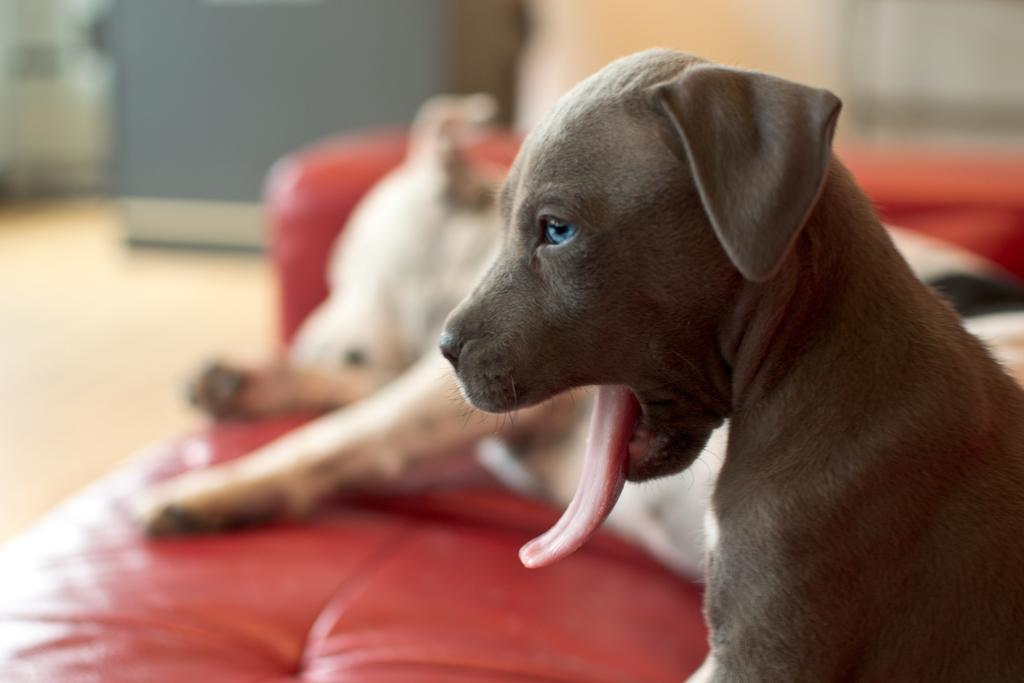What type of animals can be seen in the image? There are dogs in the image. What piece of furniture is present in the image? There is a couch in the image. What part of the room is visible in the image? The floor is visible in the image. Can you describe the background of the image? The background of the image is blurred. What type of ornament is hanging from the ceiling in the image? There is no ornament hanging from the ceiling in the image; it only features dogs, a couch, the floor, and a blurred background. 